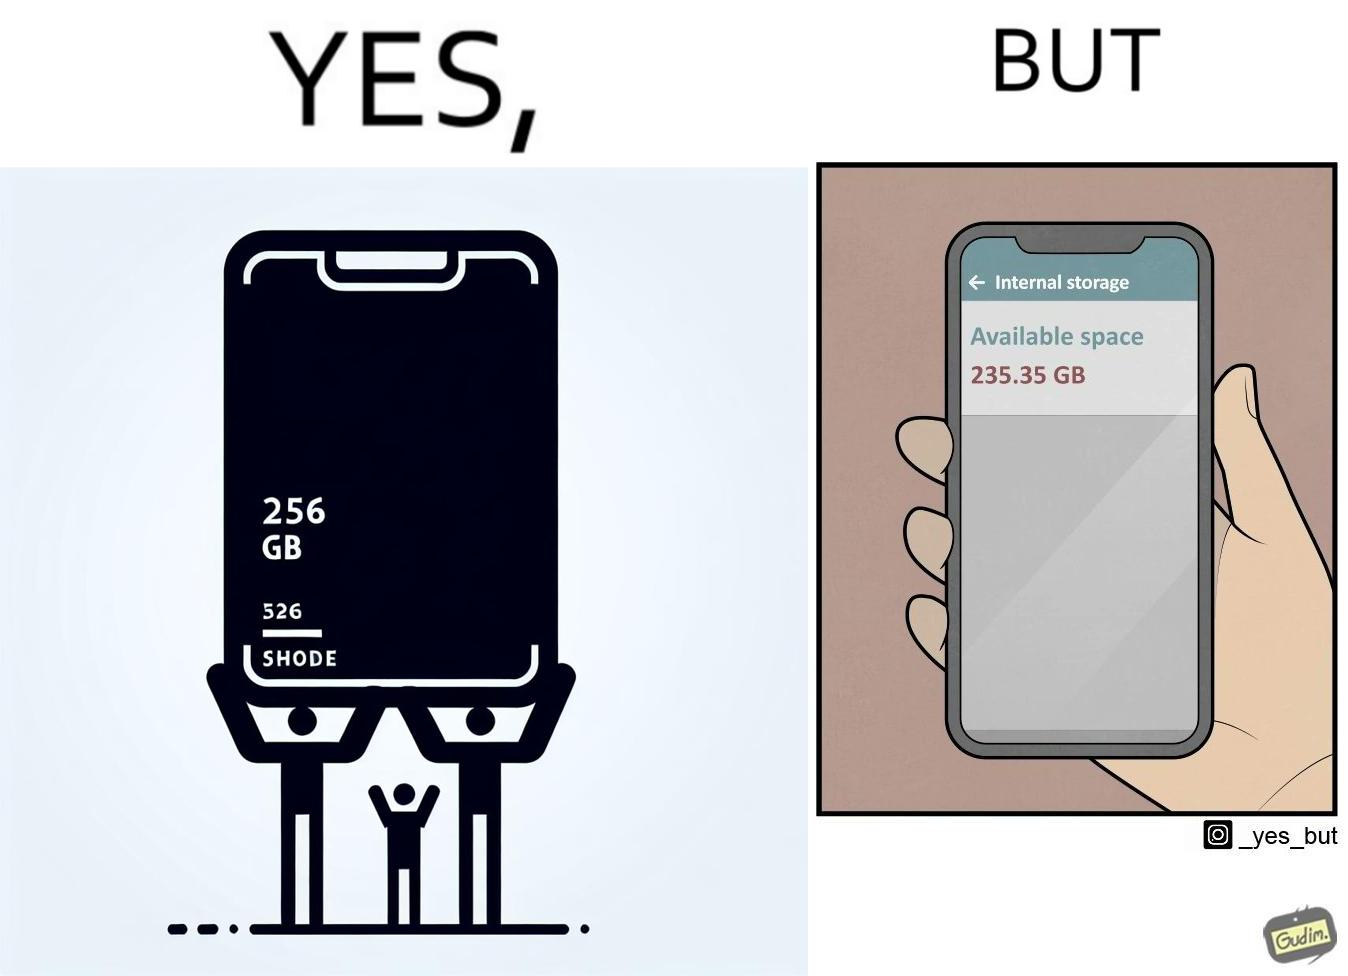What does this image depict? The images are funny since they show how smartphone manufacturers advertise their smartphones to have a high internal storage space but in reality, the amount of space available to an user is considerably less due to pre-installed software 